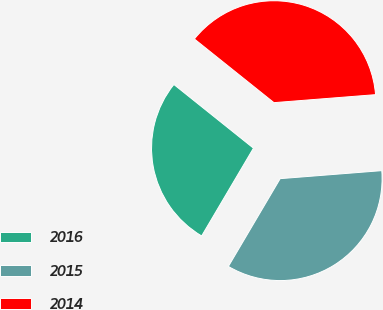Convert chart to OTSL. <chart><loc_0><loc_0><loc_500><loc_500><pie_chart><fcel>2016<fcel>2015<fcel>2014<nl><fcel>27.26%<fcel>34.74%<fcel>38.01%<nl></chart> 